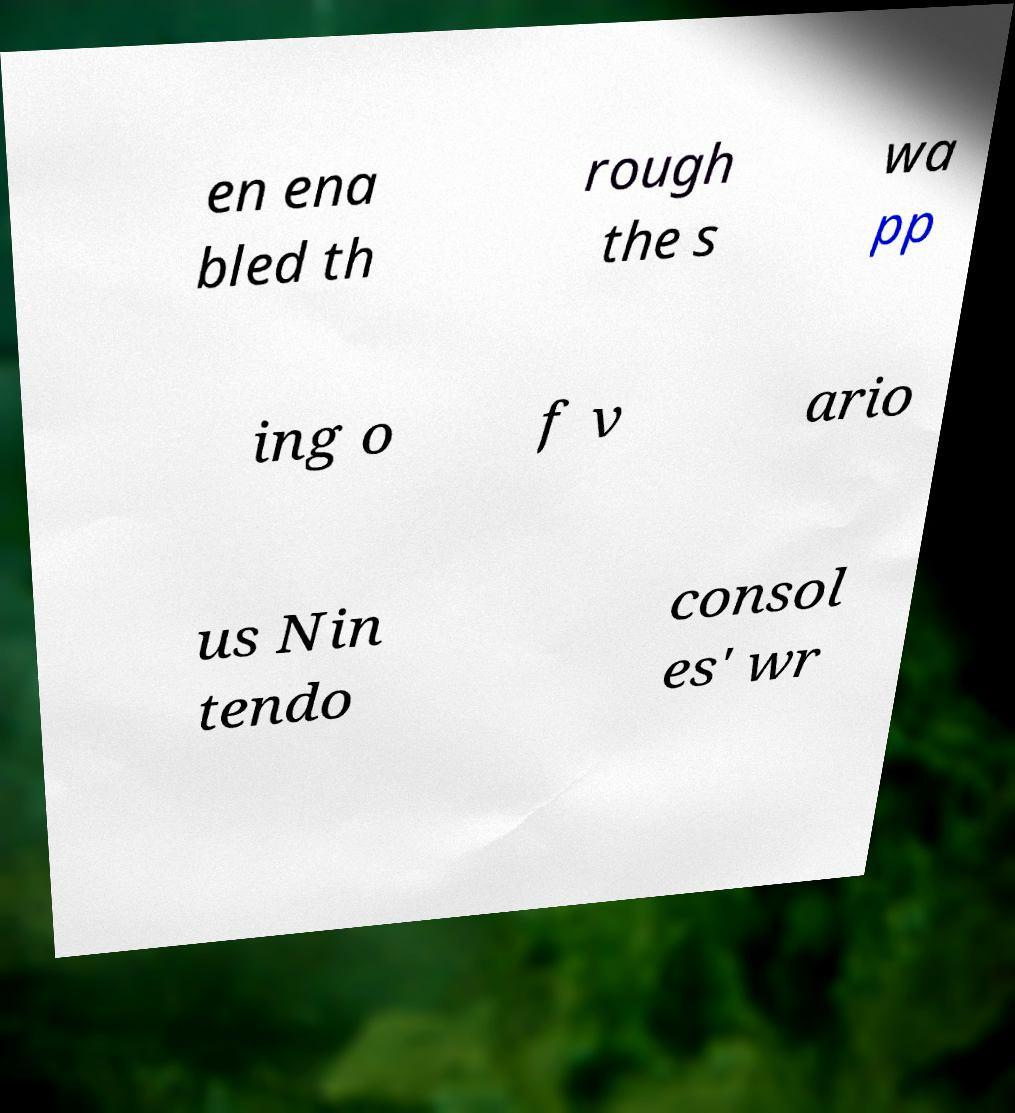What messages or text are displayed in this image? I need them in a readable, typed format. en ena bled th rough the s wa pp ing o f v ario us Nin tendo consol es' wr 